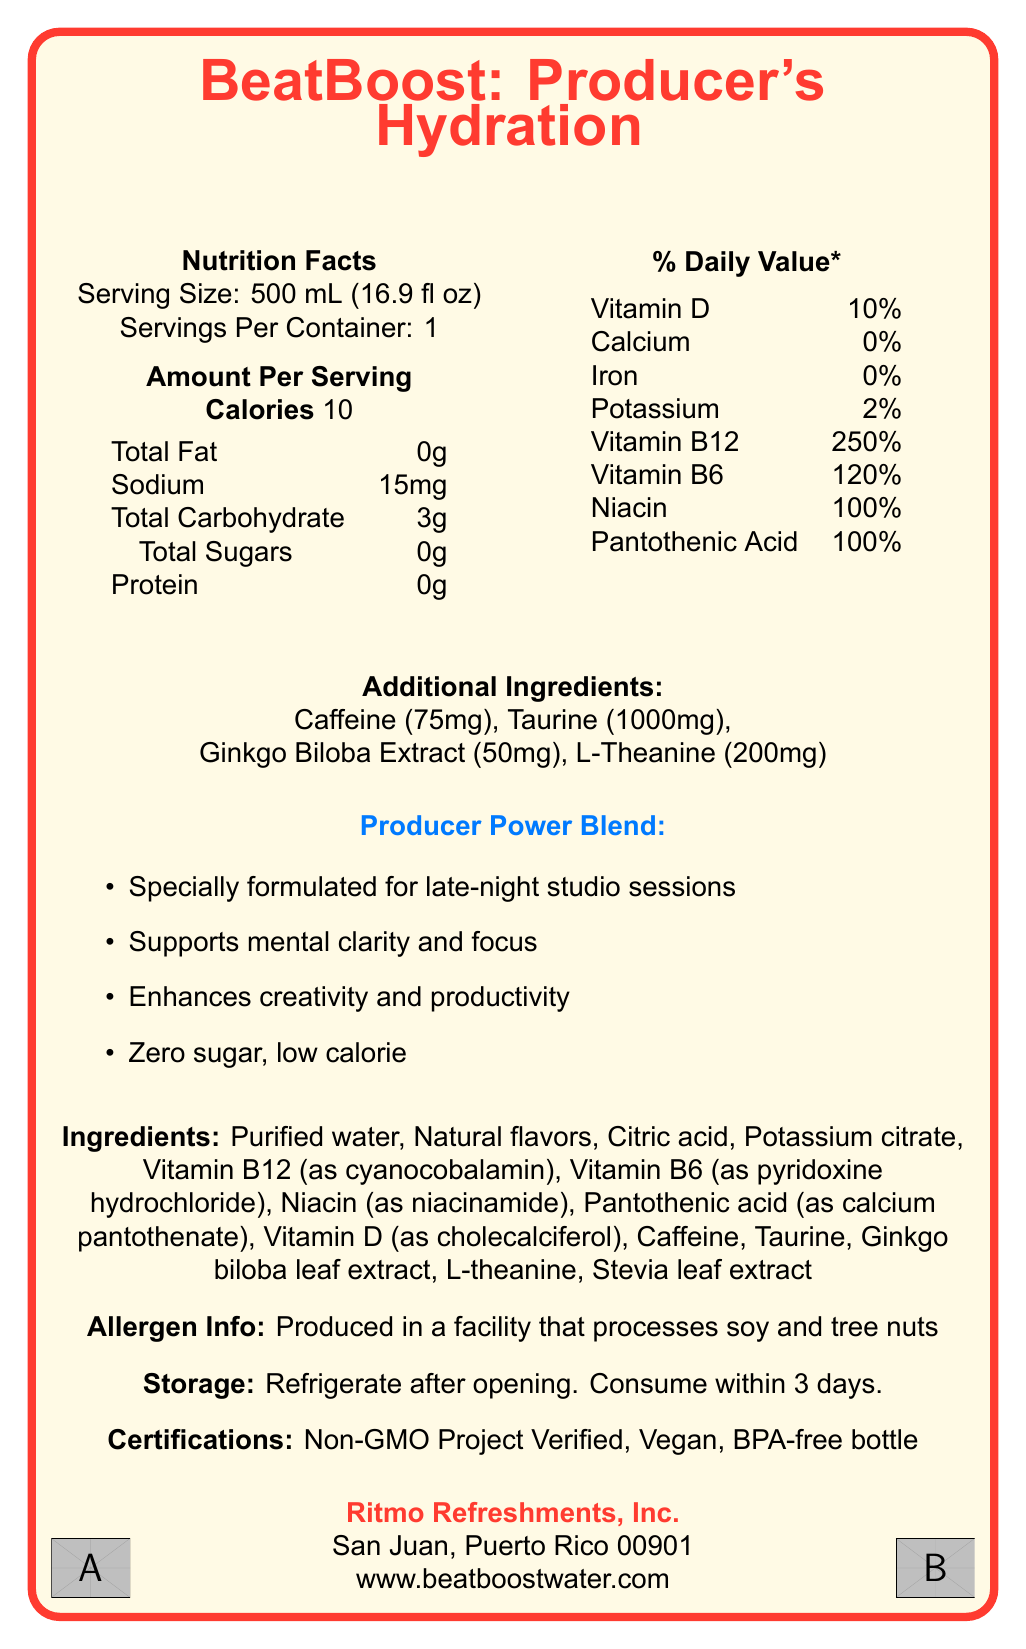What is the serving size for BeatBoost: Producer's Hydration? The serving size is explicitly mentioned under the Nutrition Facts section.
Answer: 500 mL (16.9 fl oz) How many calories are there in one serving of BeatBoost: Producer's Hydration? The total calories are listed in the Amount Per Serving section.
Answer: 10 calories What are the vitamins included in BeatBoost: Producer's Hydration? The document lists the vitamins along with their corresponding daily values.
Answer: Vitamin D, Vitamin B12, Vitamin B6, Niacin, Pantothenic Acid Which ingredient provides the highest percentage of the Daily Value (DV) among vitamins? Vitamin B12 has the highest % DV listed under the Daily Value section.
Answer: Vitamin B12 (250% DV) What special blend is highlighted for BeatBoost: Producer's Hydration? The Producer Power Blend section specifically highlights this blend.
Answer: Producer Power Blend What minerals are present in BeatBoost: Producer's Hydration? A. Calcium and Iron B. Sodium and Potassium C. Zinc and Magnesium The document lists Sodium (15mg) and Potassium (100mg, 2% DV) as the minerals present.
Answer: B. Sodium and Potassium Which of the following is a marketing claim made for BeatBoost: Producer's Hydration? A. Contains electrolytes for hydration B. Specially formulated for late-night studio sessions C. Helps in muscle recovery This is listed under the Producer Power Blend section.
Answer: B. Specially formulated for late-night studio sessions Is BeatBoost: Producer's Hydration gluten-free? The document does not provide information on whether the product is gluten-free.
Answer: Not enough information Does BeatBoost: Producer's Hydration contain any sugar? The Total Sugars content is listed as 0g under the Nutrition Facts section.
Answer: No True or False: BeatBoost: Producer's Hydration contains artificial flavors. The ingredients list mentions "Natural flavors," not artificial.
Answer: False What should you do after opening a bottle of BeatBoost: Producer's Hydration? This instruction is provided in the Storage section.
Answer: Refrigerate after opening. Consume within 3 days. Which organization certifies that BeatBoost: Producer's Hydration is non-GMO? This certification is listed under the Certifications section.
Answer: Non-GMO Project Verified Describe the main idea of the document. The document organizes an extensive amount of nutritional information and marketing details aimed at a specific target audience of music producers.
Answer: The document provides detailed nutrition information about BeatBoost: Producer's Hydration, a vitamin-enhanced bottled water marketed towards music producers. It outlines the serving size, caloric content, vitamins, minerals, special blends, ingredients, allergen info, storage instructions, certifications, and marketing claims. Who manufactures BeatBoost: Producer's Hydration? The manufacturer's name is listed at the bottom of the document.
Answer: Ritmo Refreshments, Inc. 